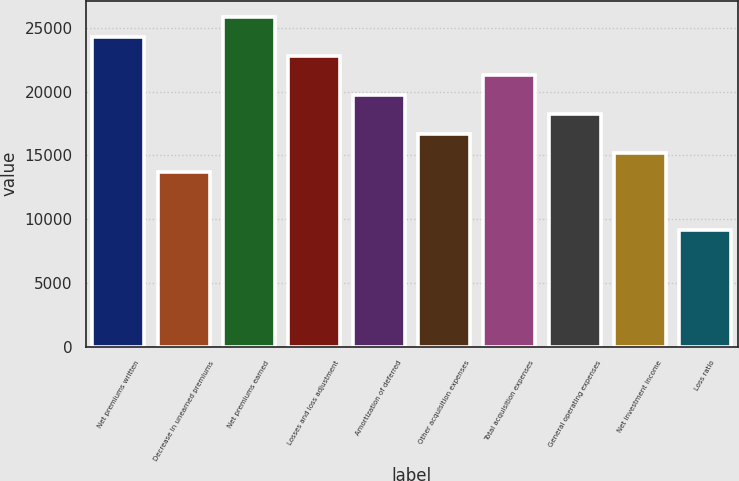Convert chart. <chart><loc_0><loc_0><loc_500><loc_500><bar_chart><fcel>Net premiums written<fcel>Decrease in unearned premiums<fcel>Net premiums earned<fcel>Losses and loss adjustment<fcel>Amortization of deferred<fcel>Other acquisition expenses<fcel>Total acquisition expenses<fcel>General operating expenses<fcel>Net investment income<fcel>Loss ratio<nl><fcel>24305.5<fcel>13671.9<fcel>25824.6<fcel>22786.4<fcel>19748.2<fcel>16710.1<fcel>21267.3<fcel>18229.2<fcel>15191<fcel>9114.68<nl></chart> 